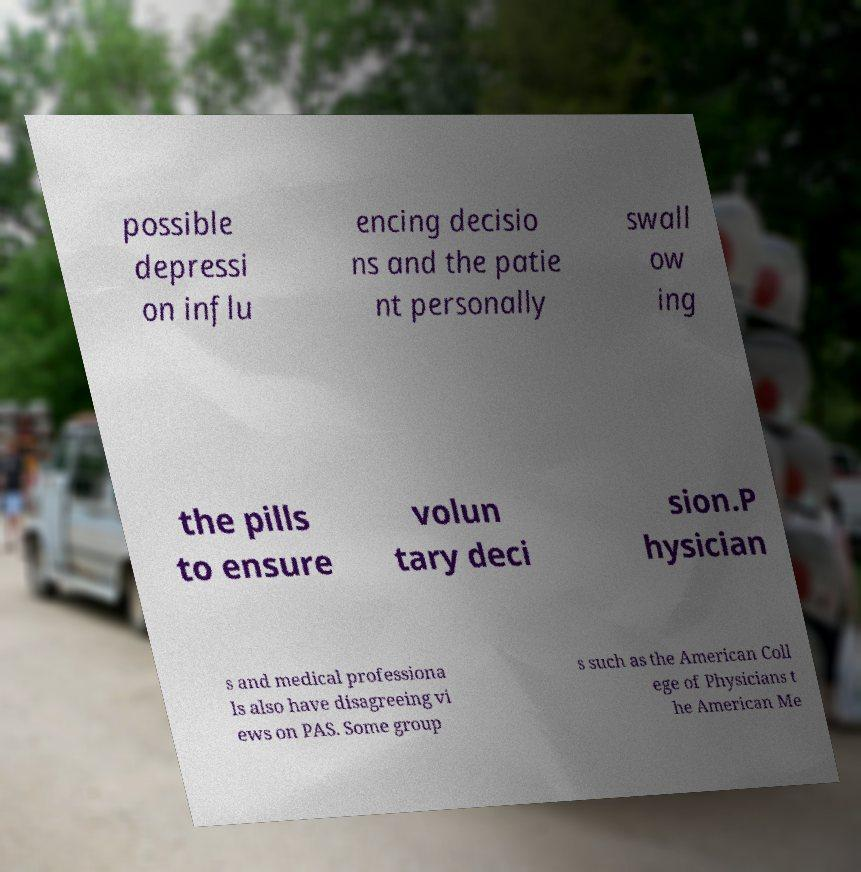Can you read and provide the text displayed in the image?This photo seems to have some interesting text. Can you extract and type it out for me? possible depressi on influ encing decisio ns and the patie nt personally swall ow ing the pills to ensure volun tary deci sion.P hysician s and medical professiona ls also have disagreeing vi ews on PAS. Some group s such as the American Coll ege of Physicians t he American Me 